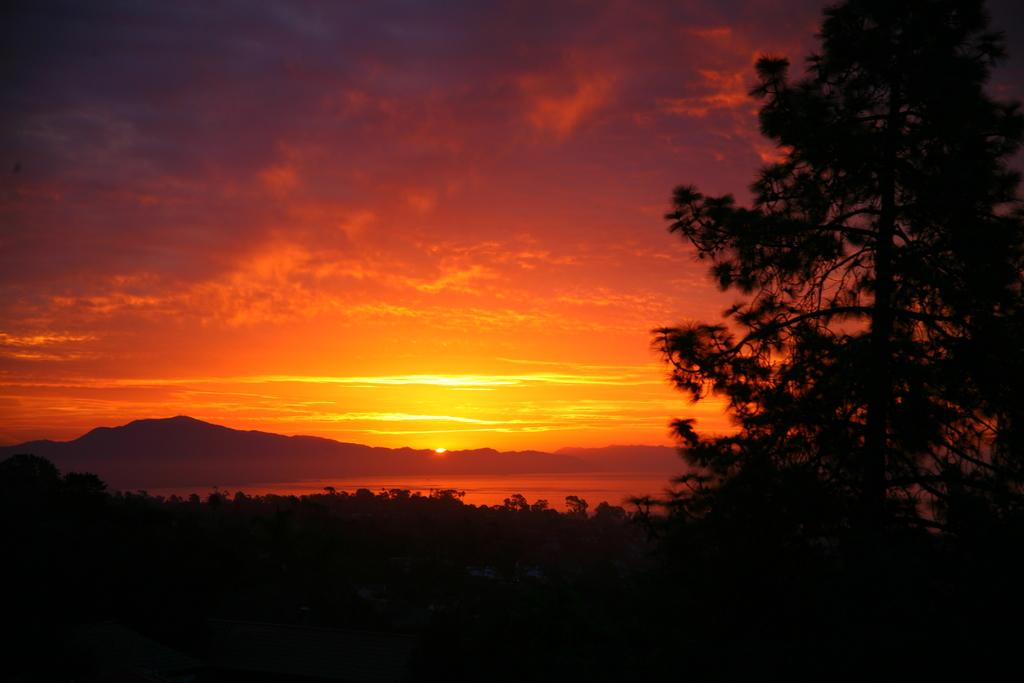What type of natural environment is depicted in the image? The image features trees, water, mountains, and a sky with clouds, which suggests a natural landscape. Can you describe the water in the image? There is water visible in the image, but its specific characteristics are not mentioned in the facts. What is the weather like in the image? The presence of clouds and sunlight in the sky suggests a partly cloudy day. How many elements of the natural environment can be seen in the image? Five elements of the natural environment are mentioned in the facts: trees, water, mountains, sky, and clouds. What type of cough medicine is visible in the image? There is no cough medicine present in the image; it features a natural landscape with trees, water, mountains, and a sky with clouds. Can you tell me how many tigers are swimming in the water in the image? There are no tigers present in the image; it features a natural landscape with trees, water, mountains, and a sky with clouds. 